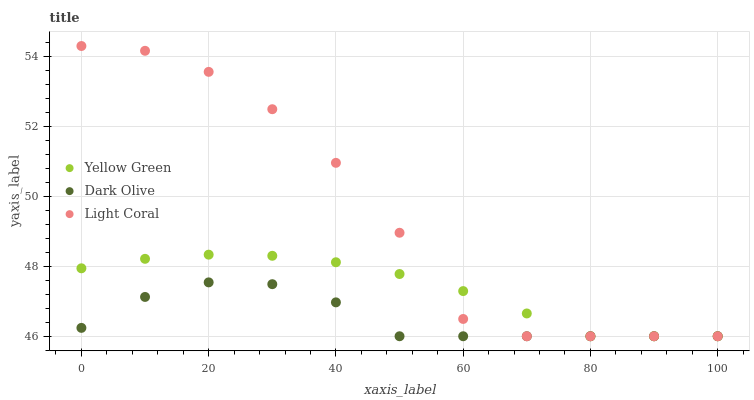Does Dark Olive have the minimum area under the curve?
Answer yes or no. Yes. Does Light Coral have the maximum area under the curve?
Answer yes or no. Yes. Does Yellow Green have the minimum area under the curve?
Answer yes or no. No. Does Yellow Green have the maximum area under the curve?
Answer yes or no. No. Is Yellow Green the smoothest?
Answer yes or no. Yes. Is Light Coral the roughest?
Answer yes or no. Yes. Is Dark Olive the smoothest?
Answer yes or no. No. Is Dark Olive the roughest?
Answer yes or no. No. Does Light Coral have the lowest value?
Answer yes or no. Yes. Does Light Coral have the highest value?
Answer yes or no. Yes. Does Yellow Green have the highest value?
Answer yes or no. No. Does Dark Olive intersect Yellow Green?
Answer yes or no. Yes. Is Dark Olive less than Yellow Green?
Answer yes or no. No. Is Dark Olive greater than Yellow Green?
Answer yes or no. No. 